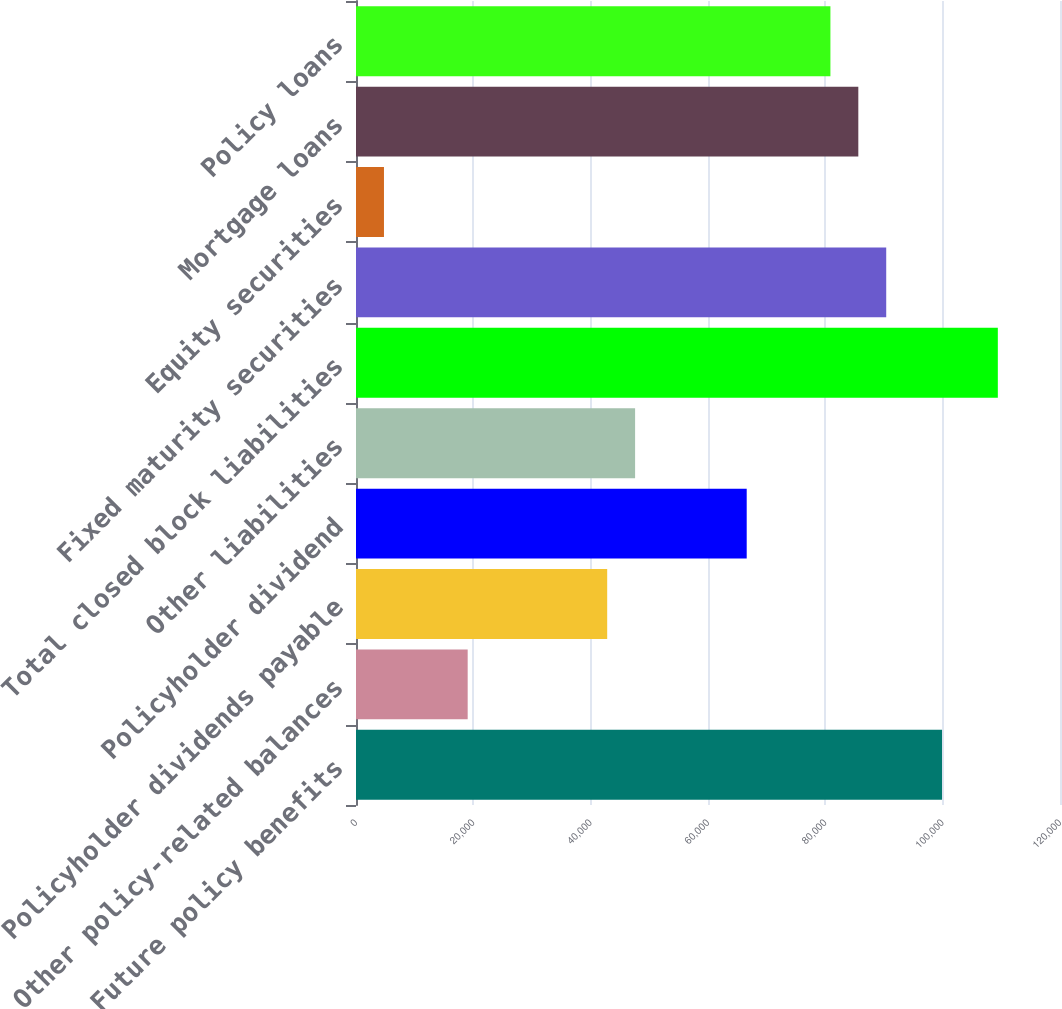Convert chart to OTSL. <chart><loc_0><loc_0><loc_500><loc_500><bar_chart><fcel>Future policy benefits<fcel>Other policy-related balances<fcel>Policyholder dividends payable<fcel>Policyholder dividend<fcel>Other liabilities<fcel>Total closed block liabilities<fcel>Fixed maturity securities<fcel>Equity securities<fcel>Mortgage loans<fcel>Policy loans<nl><fcel>99891.2<fcel>19035.8<fcel>42816.8<fcel>66597.8<fcel>47573<fcel>109404<fcel>90378.8<fcel>4767.2<fcel>85622.6<fcel>80866.4<nl></chart> 